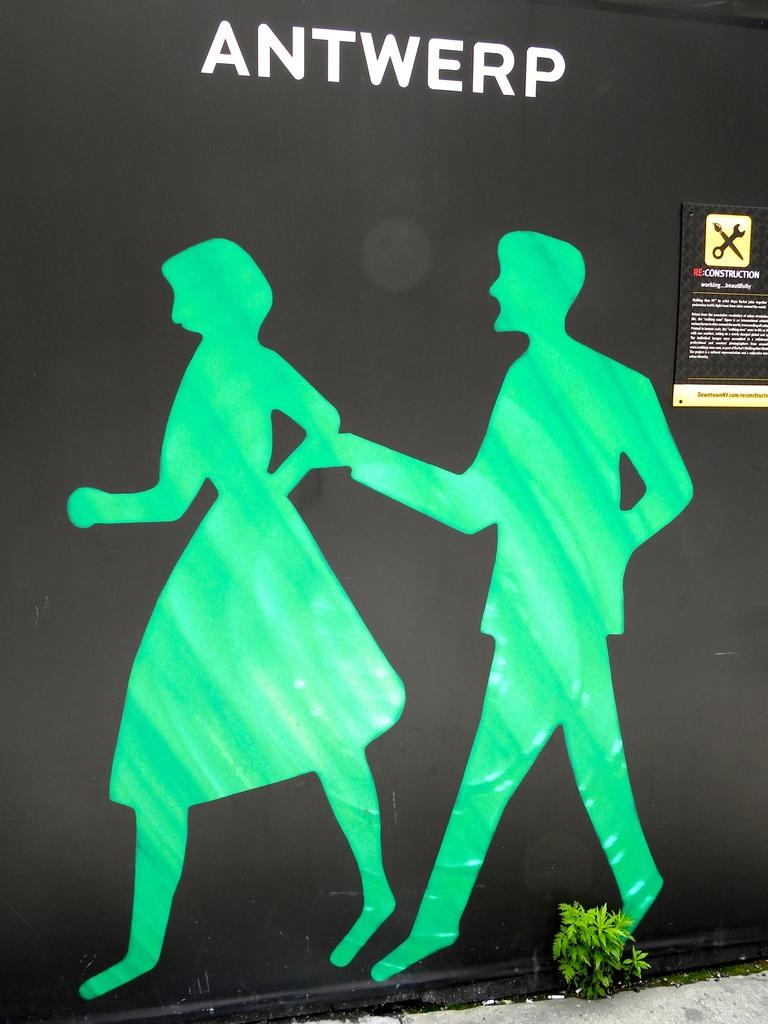<image>
Relay a brief, clear account of the picture shown. A silhouette of a man and a woman in green on a black background with the word Antwerp at the top 